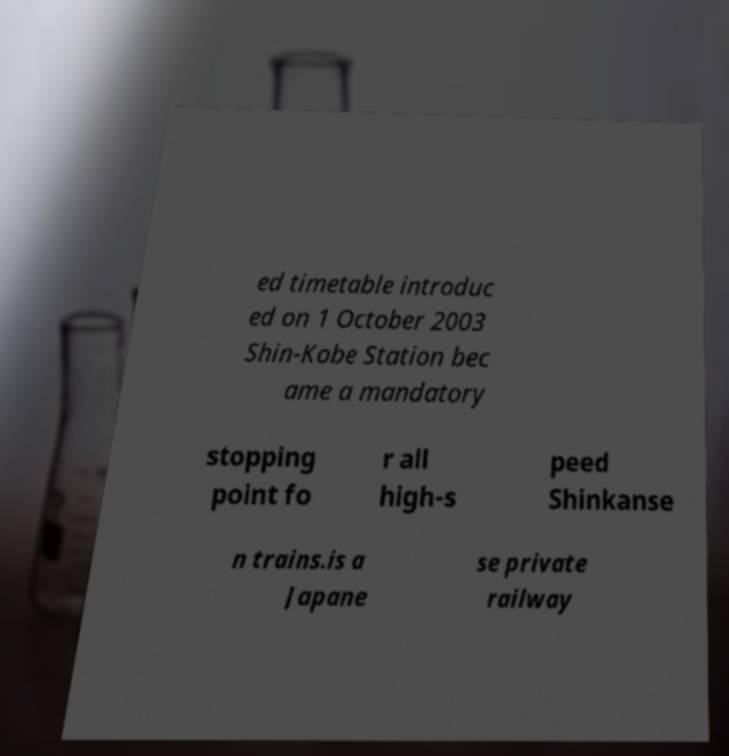Please read and relay the text visible in this image. What does it say? ed timetable introduc ed on 1 October 2003 Shin-Kobe Station bec ame a mandatory stopping point fo r all high-s peed Shinkanse n trains.is a Japane se private railway 